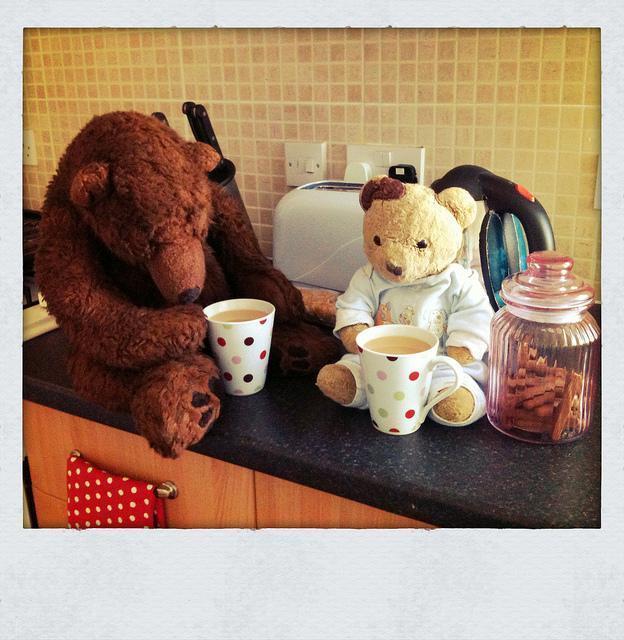How many bears are there?
Give a very brief answer. 2. How many cups are in the photo?
Give a very brief answer. 2. How many teddy bears are there?
Give a very brief answer. 2. How many white boats are to the side of the building?
Give a very brief answer. 0. 